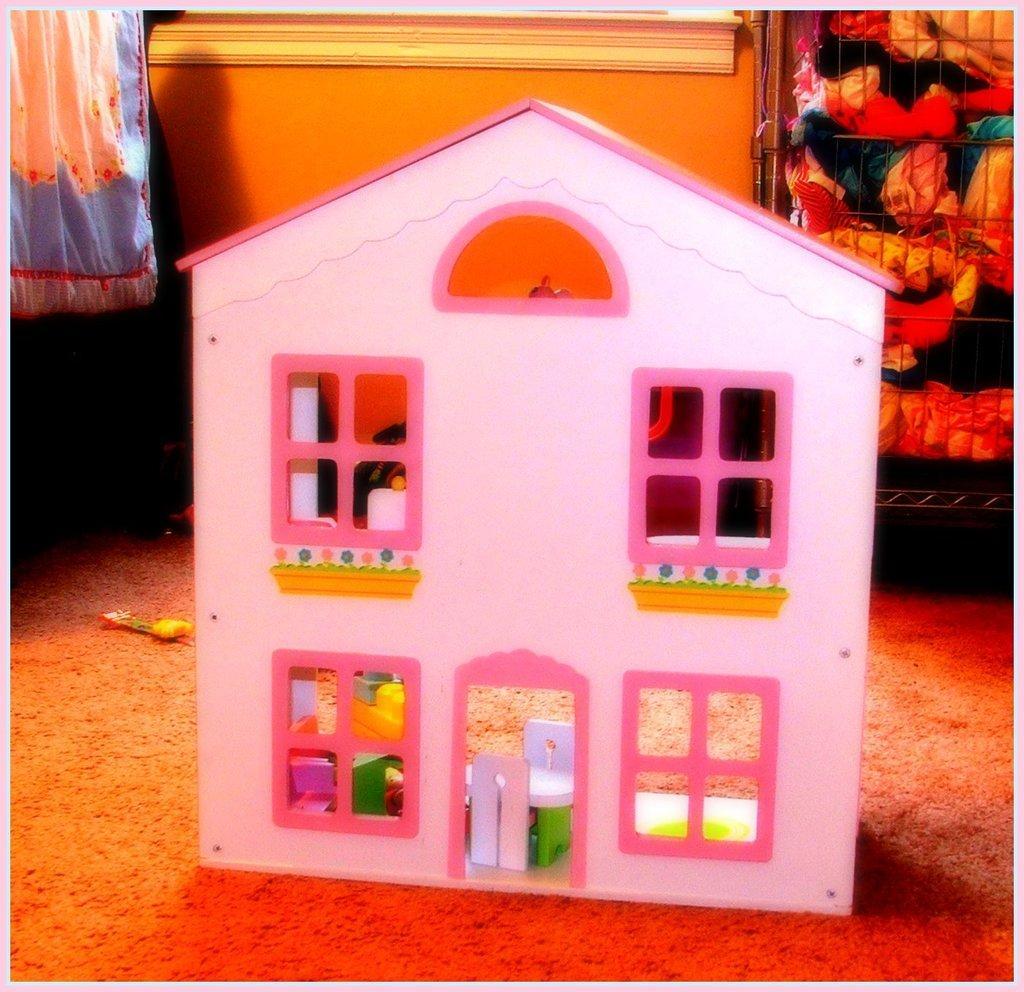How would you summarize this image in a sentence or two? In this image there is a toy house which is made up of cardboard. In the background there is a curtain on the left side top corner. On the right side top corner there is a grill. In the grill there are clothes. In the background there is a wall. 